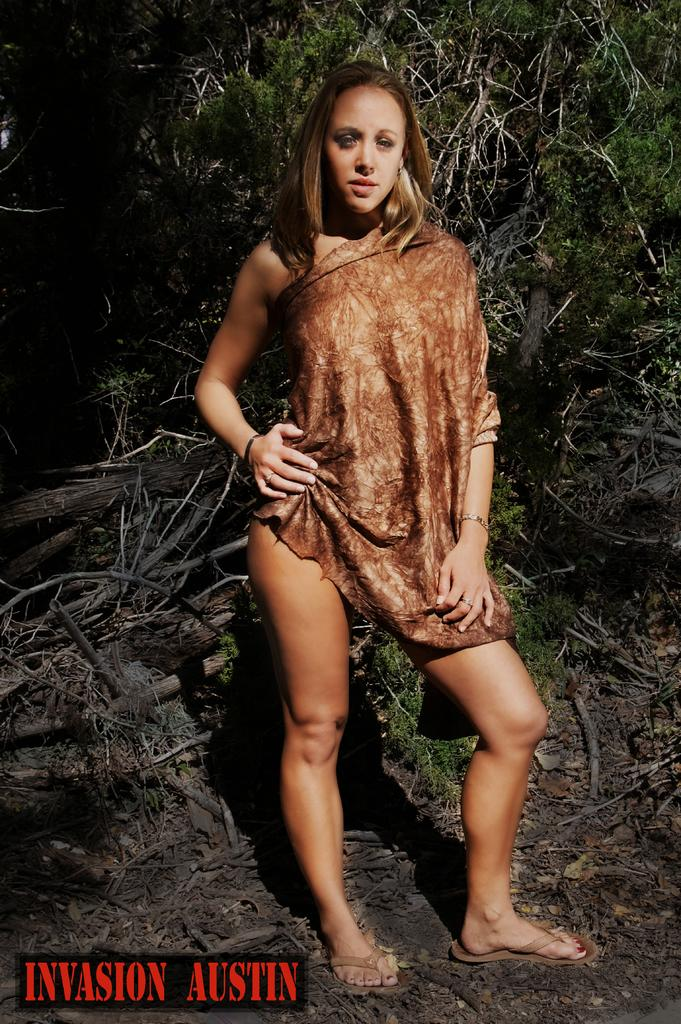What is the main subject of the image? There is a woman standing in the image. What is the woman doing in the image? The woman is watching something. What can be seen in the background of the image? There are trees and twigs in the background of the image. Is there any additional information about the image itself? Yes, there is a watermark in the left side bottom corner of the image. What type of scale is the woman using to weigh the yoke in the image? There is no scale or yoke present in the image; it features a woman standing and watching something. Does the existence of the woman in the image prove the existence of a parallel universe? The presence of the woman in the image does not prove the existence of a parallel universe, as the image only shows a woman standing and watching something in a specific setting. 